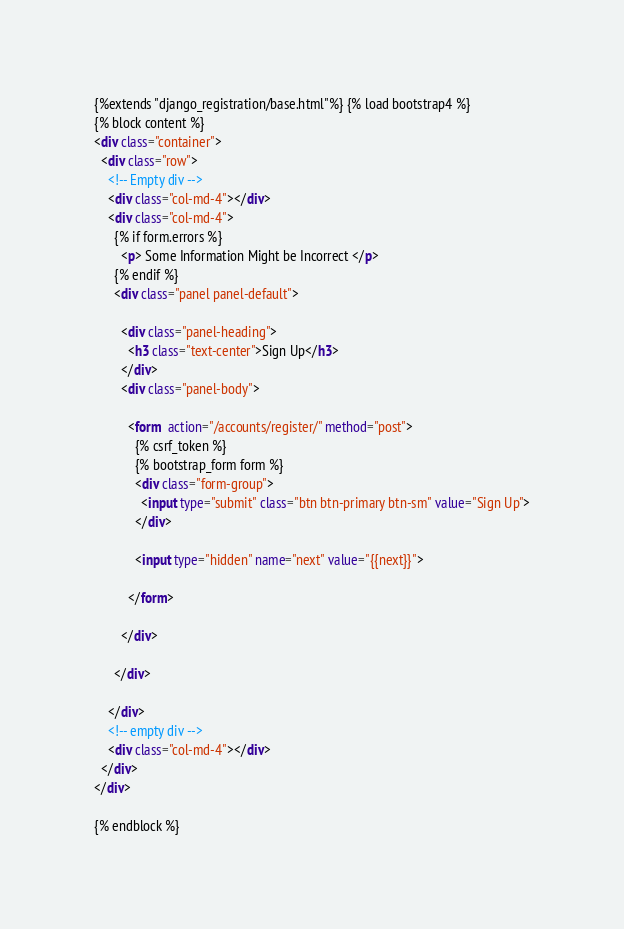<code> <loc_0><loc_0><loc_500><loc_500><_HTML_>{%extends "django_registration/base.html"%} {% load bootstrap4 %}
{% block content %}
<div class="container">
  <div class="row">
    <!-- Empty div -->
    <div class="col-md-4"></div>
    <div class="col-md-4">
      {% if form.errors %}
        <p> Some Information Might be Incorrect </p>
      {% endif %}
      <div class="panel panel-default">

        <div class="panel-heading">
          <h3 class="text-center">Sign Up</h3>
        </div>
        <div class="panel-body">

          <form  action="/accounts/register/" method="post">
            {% csrf_token %}
            {% bootstrap_form form %}
            <div class="form-group">
              <input type="submit" class="btn btn-primary btn-sm" value="Sign Up">
            </div>

            <input type="hidden" name="next" value="{{next}}">

          </form>

        </div>

      </div>

    </div>
    <!-- empty div -->
    <div class="col-md-4"></div>
  </div>
</div>

{% endblock %}</code> 